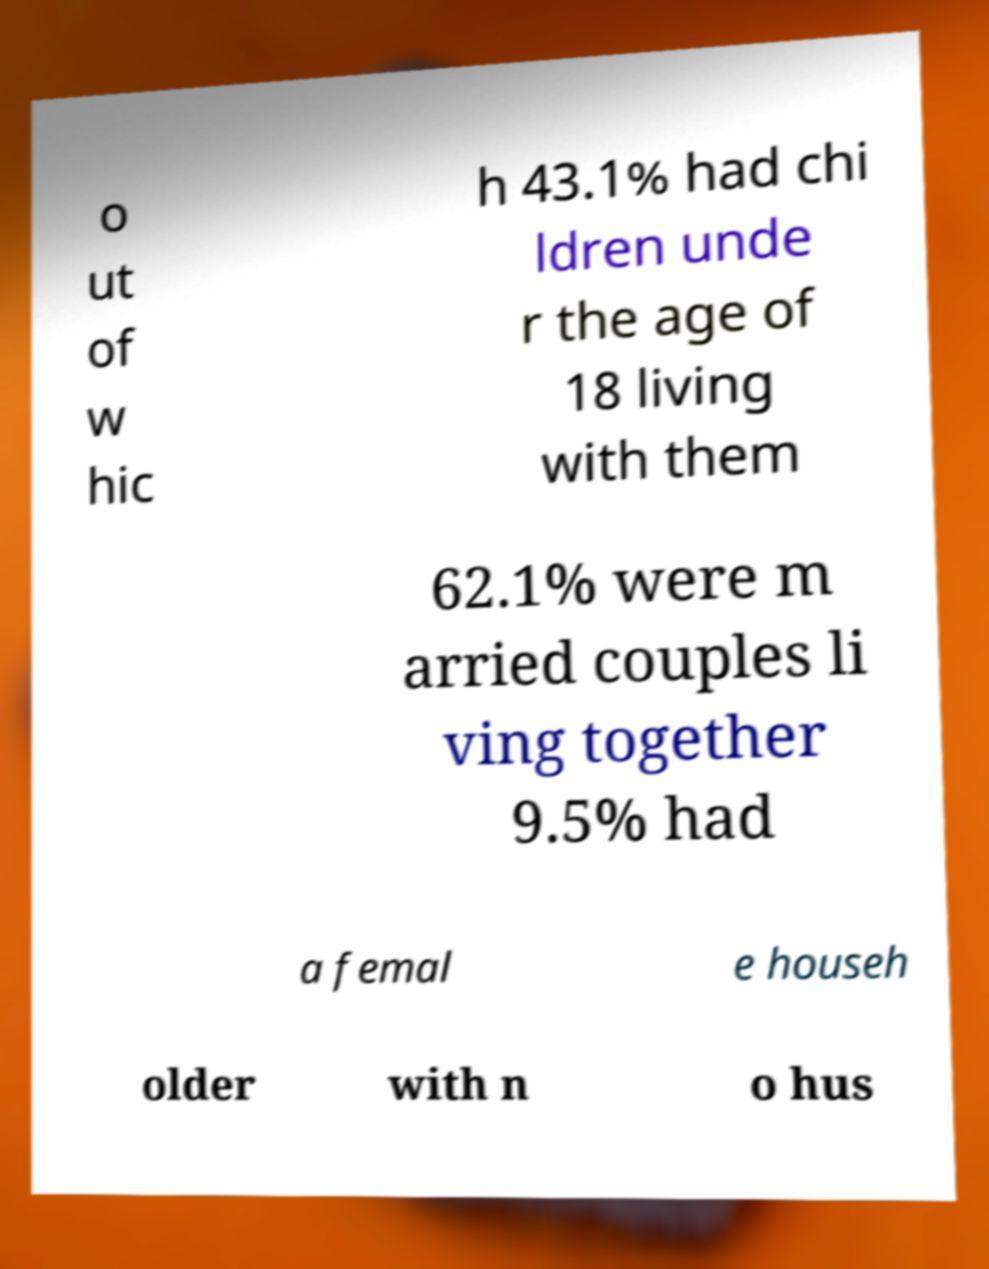Please read and relay the text visible in this image. What does it say? o ut of w hic h 43.1% had chi ldren unde r the age of 18 living with them 62.1% were m arried couples li ving together 9.5% had a femal e househ older with n o hus 